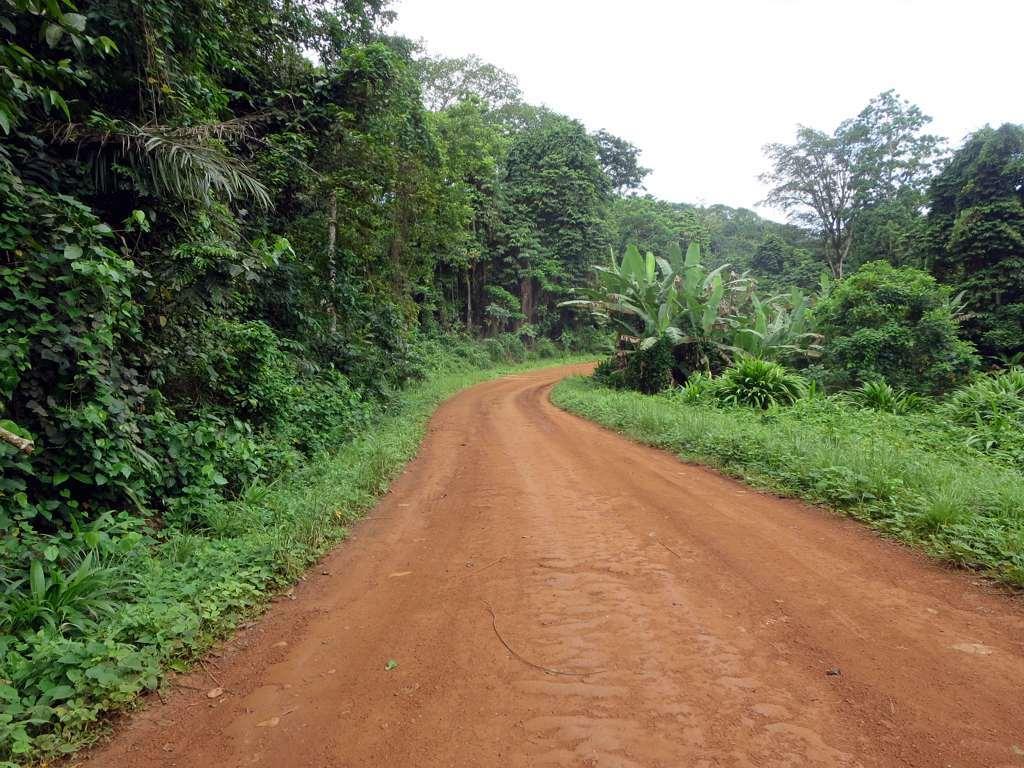Can you describe this image briefly? In this image there is a road in the bottom of this image and there are some trees in the background. There is a sky on the top of this image. 